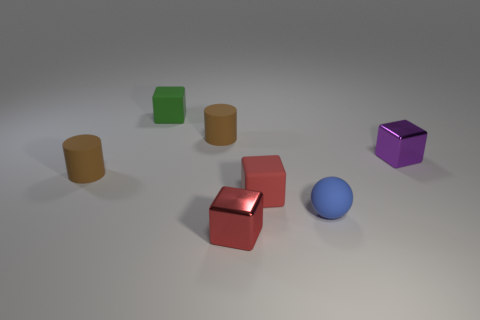How many small purple cubes are left of the red block that is in front of the small matte block in front of the green matte cube?
Provide a short and direct response. 0. There is a matte object that is both behind the tiny red matte block and on the right side of the small green matte thing; what color is it?
Ensure brevity in your answer.  Brown. How many balls are red rubber objects or brown matte objects?
Offer a very short reply. 0. What is the color of the matte sphere that is the same size as the green object?
Your answer should be compact. Blue. Are there any small purple things behind the tiny cylinder that is behind the tiny metal block right of the tiny red rubber cube?
Your response must be concise. No. What is the size of the green matte cube?
Make the answer very short. Small. How many things are either green cubes or small red things?
Your answer should be very brief. 3. There is a cube that is made of the same material as the tiny green object; what color is it?
Your answer should be compact. Red. Do the tiny metal thing that is on the right side of the tiny blue sphere and the green matte object have the same shape?
Offer a terse response. Yes. How many objects are tiny metallic things on the left side of the small blue ball or small things to the right of the green thing?
Offer a very short reply. 5. 